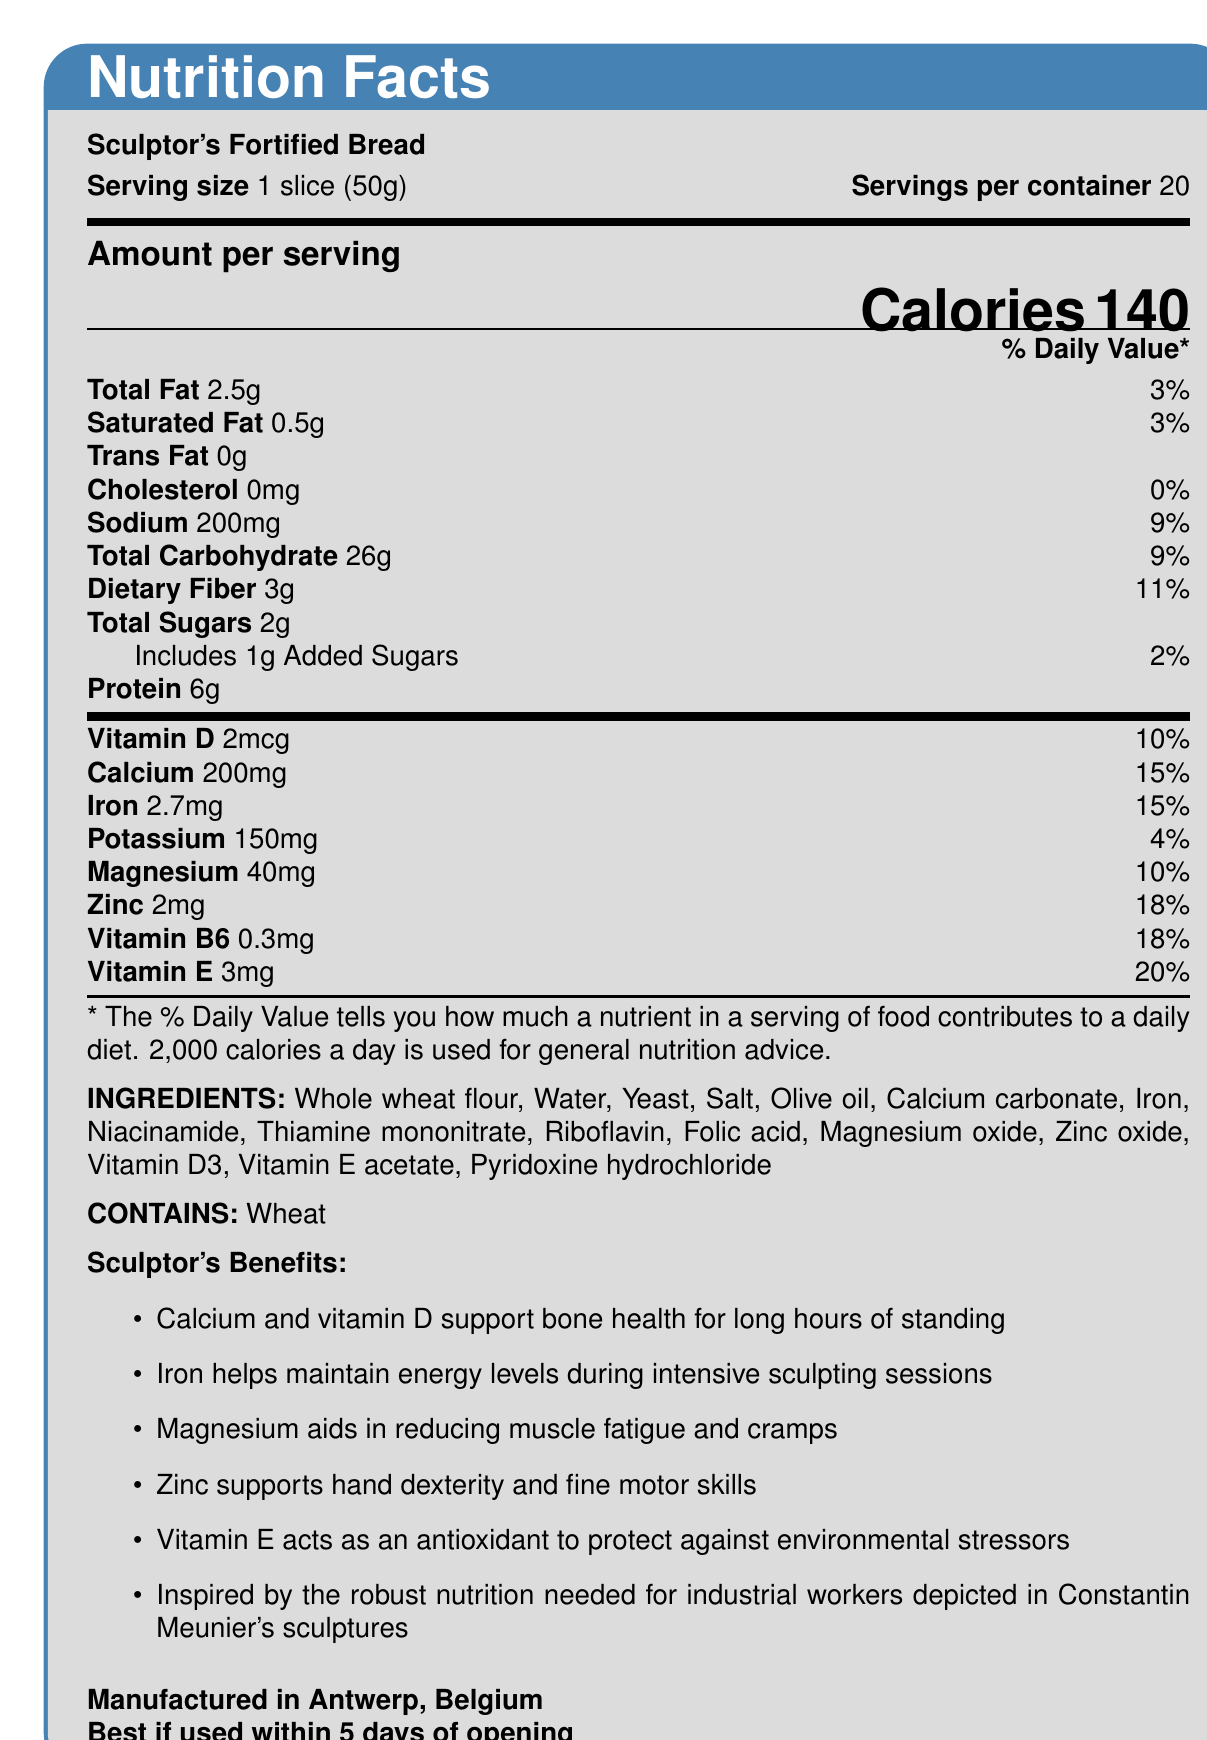what is the serving size of Sculptor's Fortified Bread? The document specifies the serving size as "1 slice (50g)" in the nutrition facts section.
Answer: 1 slice (50g) how many calories are there per serving? The document clearly states that a serving contains "140" calories.
Answer: 140 how much total fat is in one serving, and what is its daily value percentage? The document lists total fat as "2.5g" and indicates its daily value percentage as "3%".
Answer: 2.5g, 3% what are the main benefits of magnesium in Sculptor's Fortified Bread? The sculptor-specific benefits section mentions that "Magnesium aids in reducing muscle fatigue and cramps".
Answer: Magnesium aids in reducing muscle fatigue and cramps how many servings are there in one container of Sculptor's Fortified Bread? The document states "Servings per container: 20".
Answer: 20 which vitamin has the highest daily value percentage in Sculptor's Fortified Bread? A. Vitamin D B. Calcium C. Vitamin B6 D. Vitamin E Vitamin E has a daily value percentage of 20%, which is the highest among the listed vitamins.
Answer: D what can be found under the allergen information in the document? A. Contains: Dairy B. Contains: Wheat C. Contains: Soy D. Contains: Tree Nuts The document specifies "Contains: Wheat" under the allergen information.
Answer: B is there any trans fat in Sculptor's Fortified Bread? The document states that the amount of trans fat is "0g".
Answer: No where is Sculptor's Fortified Bread manufactured? The manufacturing location is specified as "Antwerp, Belgium".
Answer: Antwerp, Belgium describe the main idea of the document. The document offers nutritional information, health claims, and the sculptor-specific benefits of the fortified bread, emphasizing the added vitamins and minerals tailored to the needs of sculptors inspired by Constantin Meunier's work.
Answer: The document provides detailed nutrition facts, ingredient lists, and specific health benefits of Sculptor's Fortified Bread, which is fortified with essential vitamins and minerals to support the well-being of sculptors, namely in muscle function, bone health, and energy levels. Additionally, it highlights sculptor-specific benefits inspired by Constantin Meunier's workers' iconography. what are the main ingredients of Sculptor's Fortified Bread? The document provides a comprehensive list of ingredients under the "INGREDIENTS" section.
Answer: Whole wheat flour, Water, Yeast, Salt, Olive oil, Calcium carbonate, Iron, Niacinamide, Thiamine mononitrate, Riboflavin, Folic acid, Magnesium oxide, Zinc oxide, Vitamin D3, Vitamin E acetate, Pyridoxine hydrochloride how much calcium does one serving provide, and what percentage of the daily value does it represent? The document specifies that one serving provides "200mg" of calcium, which is "15%" of the daily value.
Answer: 200mg, 15% what are the health benefits of zinc in Sculptor's Fortified Bread? The sculptor-specific benefits section mentions that "Zinc supports hand dexterity and fine motor skills".
Answer: Zinc supports hand dexterity and fine motor skills how can the bread best support bone health for sculptors according to the document? The document specifically mentions the benefits of calcium and vitamin D in supporting bone health for long hours of standing as a sculptor.
Answer: Calcium and vitamin D support bone health for long hours of standing what is the main function of iron in the bread for sculptors? The document states that iron helps maintain energy levels during intensive sculpting sessions under the sculptor-specific benefits.
Answer: Iron helps maintain energy levels during intensive sculpting sessions what is the expiration guideline for Sculptor's Fortified Bread after opening? The document advises that the bread is best if used within 5 days of opening.
Answer: Best if used within 5 days of opening when was Sculptor's Fortified Bread first developed? The document does not provide a development date or timeline for the creation of Sculptor's Fortified Bread.
Answer: Not enough information 